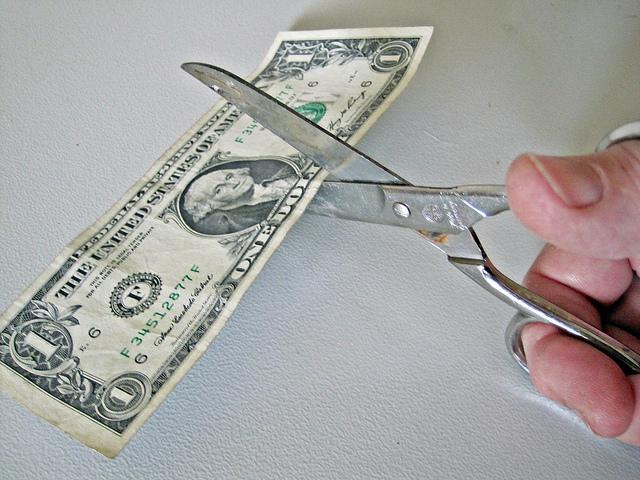When this dollar bill is cut in half, is it still legal tender?
Be succinct. No. What denomination is the bill?
Concise answer only. 1. Are the scissors new?
Keep it brief. No. Is this a man or woman that is holding the scissors?
Concise answer only. Man. Is this a ten dollar bill?
Short answer required. No. 